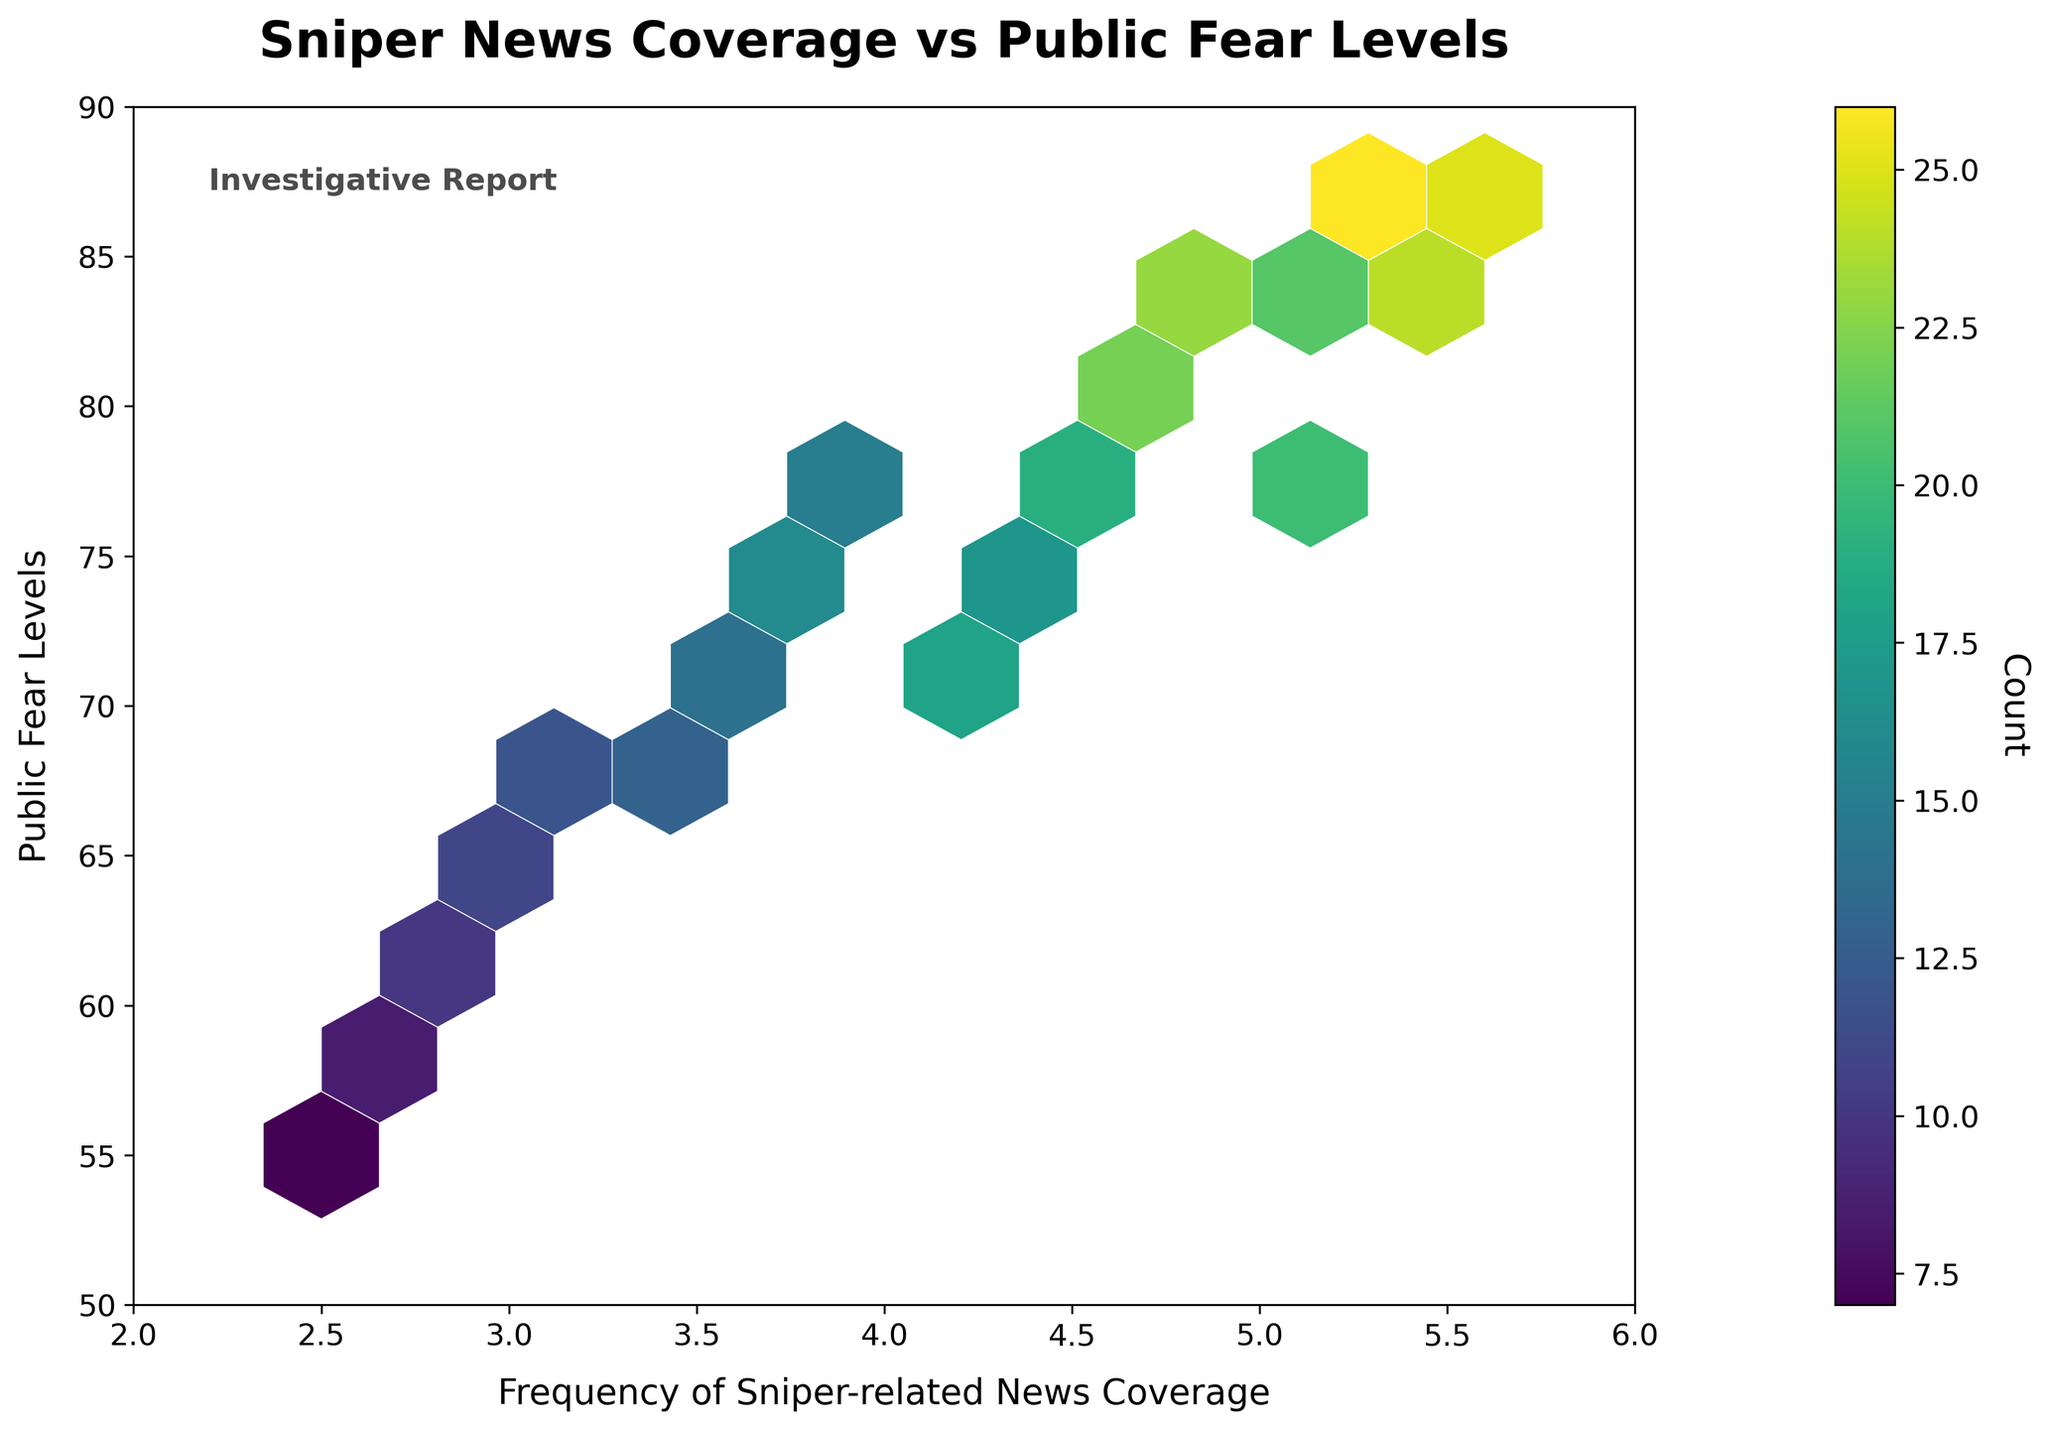What's the title of the figure? The title is located at the top of the figure and it provides an overview of what the plot is about.
Answer: Sniper News Coverage vs Public Fear Levels What is the color of the bin with the highest count? The color of the highest count bin is revealed via the colorbar on the right, which is mapped to the color scheme used in the hexbin plot.
Answer: Dark purple What does the colorbar represent? The colorbar, labeled 'Count', indicates how the different colors in the plot correspond to the number of data points within each bin.
Answer: Number of data points What are the ranges of frequency of sniper-related news coverage and public fear levels shown in the figure? The x-axis and y-axis ranges can be observed from the axis limits and tick marks.
Answer: 2 to 6 for news coverage and 50 to 90 for fear levels Which data point in the plot has the highest 'count' value, and what is that count? By identifying the darkest hexbin in the plot and cross-referencing it with the colorbar, we find the corresponding count.
Answer: The point at (5.4, 87) with a count of 26 What can you infer about the correlation between sniper news coverage and public fear levels from this plot? By observing the overall trend and density gradient in the plot, you can deduce if there is a positive, negative, or no clear correlation.
Answer: There is a positive correlation How many regions have more than 20 data points in a bin? By checking the colorbar and locating the bins whose color corresponds to counts greater than 20, you can count these bins.
Answer: Five regions Between the fear levels of 60 to 70, which frequency of sniper news coverage has the highest density? Locate the range on the fear levels (y-axis), then observe the densest hexbin within this range.
Answer: 3.5 Which region has the least public fear level and what is the frequency of news coverage in that region? Identify the lowest point on the y-axis and note its x-axis value.
Answer: The region with a fear level of 55 and a news coverage frequency of 2.5 What additional information would help in better understanding the trends observed in the figure? Points to consider include the source of the data, time span of the coverage, possible influencing factors, and statistical analysis.
Answer: More context and statistical details 